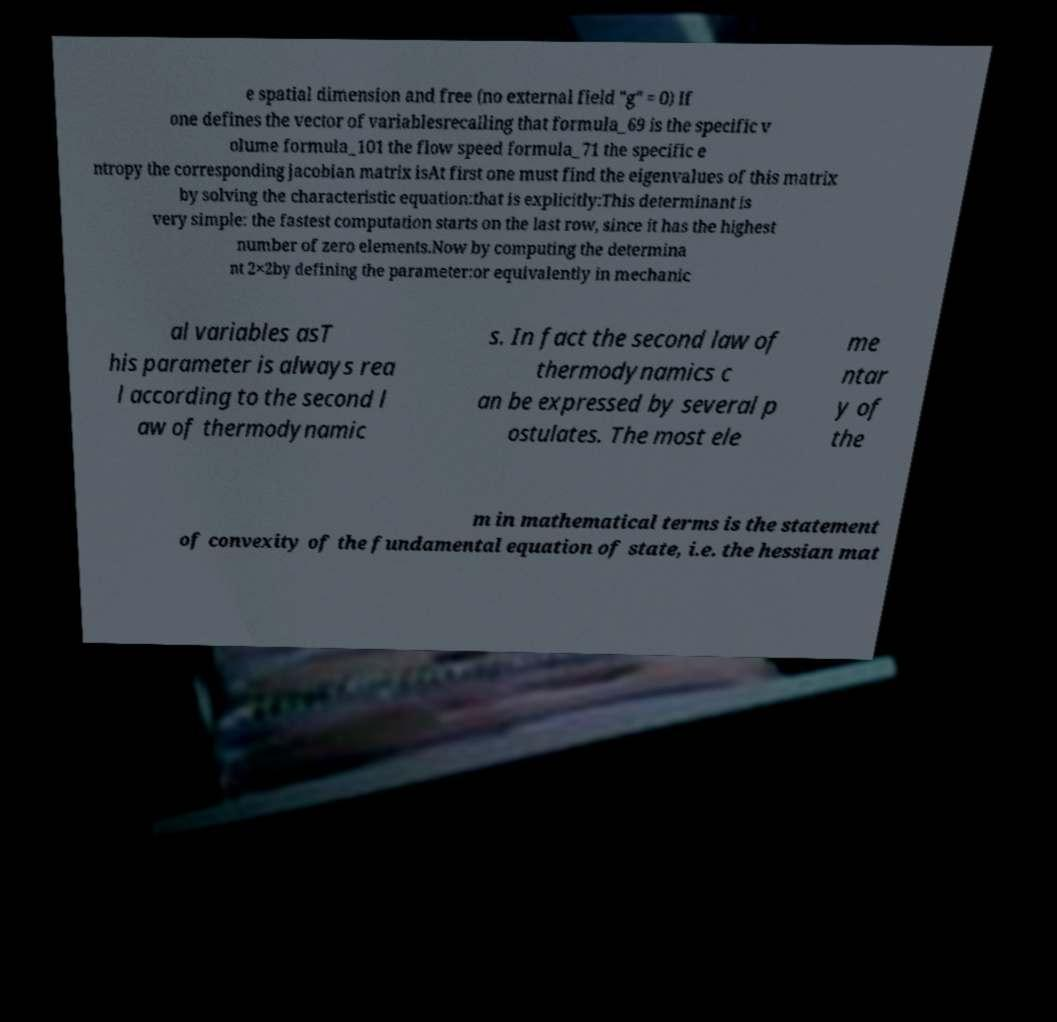Can you accurately transcribe the text from the provided image for me? e spatial dimension and free (no external field "g" = 0) If one defines the vector of variablesrecalling that formula_69 is the specific v olume formula_101 the flow speed formula_71 the specific e ntropy the corresponding jacobian matrix isAt first one must find the eigenvalues of this matrix by solving the characteristic equation:that is explicitly:This determinant is very simple: the fastest computation starts on the last row, since it has the highest number of zero elements.Now by computing the determina nt 2×2by defining the parameter:or equivalently in mechanic al variables asT his parameter is always rea l according to the second l aw of thermodynamic s. In fact the second law of thermodynamics c an be expressed by several p ostulates. The most ele me ntar y of the m in mathematical terms is the statement of convexity of the fundamental equation of state, i.e. the hessian mat 